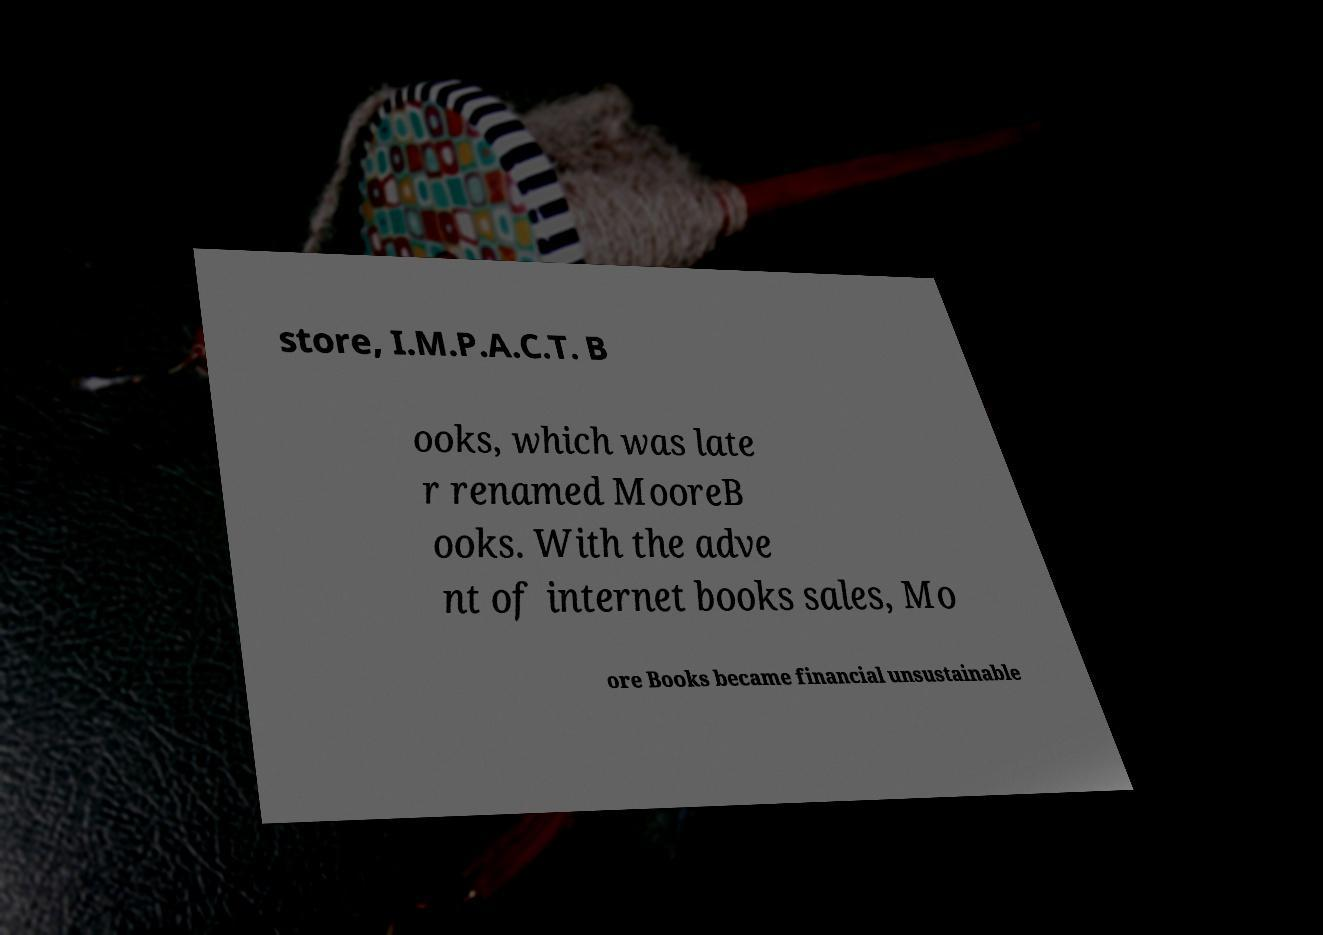What messages or text are displayed in this image? I need them in a readable, typed format. store, I.M.P.A.C.T. B ooks, which was late r renamed MooreB ooks. With the adve nt of internet books sales, Mo ore Books became financial unsustainable 